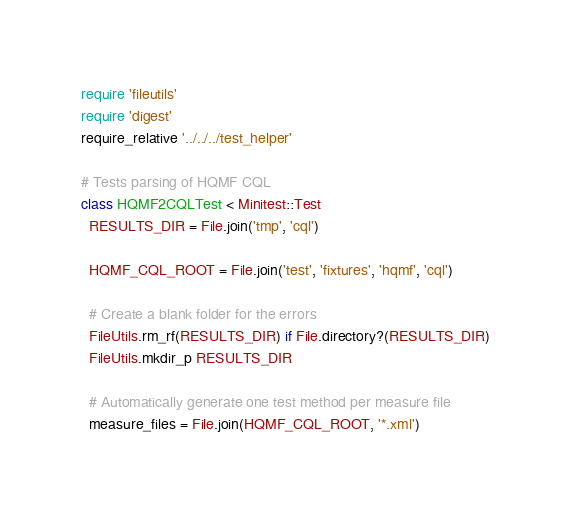<code> <loc_0><loc_0><loc_500><loc_500><_Ruby_>require 'fileutils'
require 'digest'
require_relative '../../../test_helper'

# Tests parsing of HQMF CQL
class HQMF2CQLTest < Minitest::Test
  RESULTS_DIR = File.join('tmp', 'cql')

  HQMF_CQL_ROOT = File.join('test', 'fixtures', 'hqmf', 'cql')

  # Create a blank folder for the errors
  FileUtils.rm_rf(RESULTS_DIR) if File.directory?(RESULTS_DIR)
  FileUtils.mkdir_p RESULTS_DIR

  # Automatically generate one test method per measure file
  measure_files = File.join(HQMF_CQL_ROOT, '*.xml')
</code> 